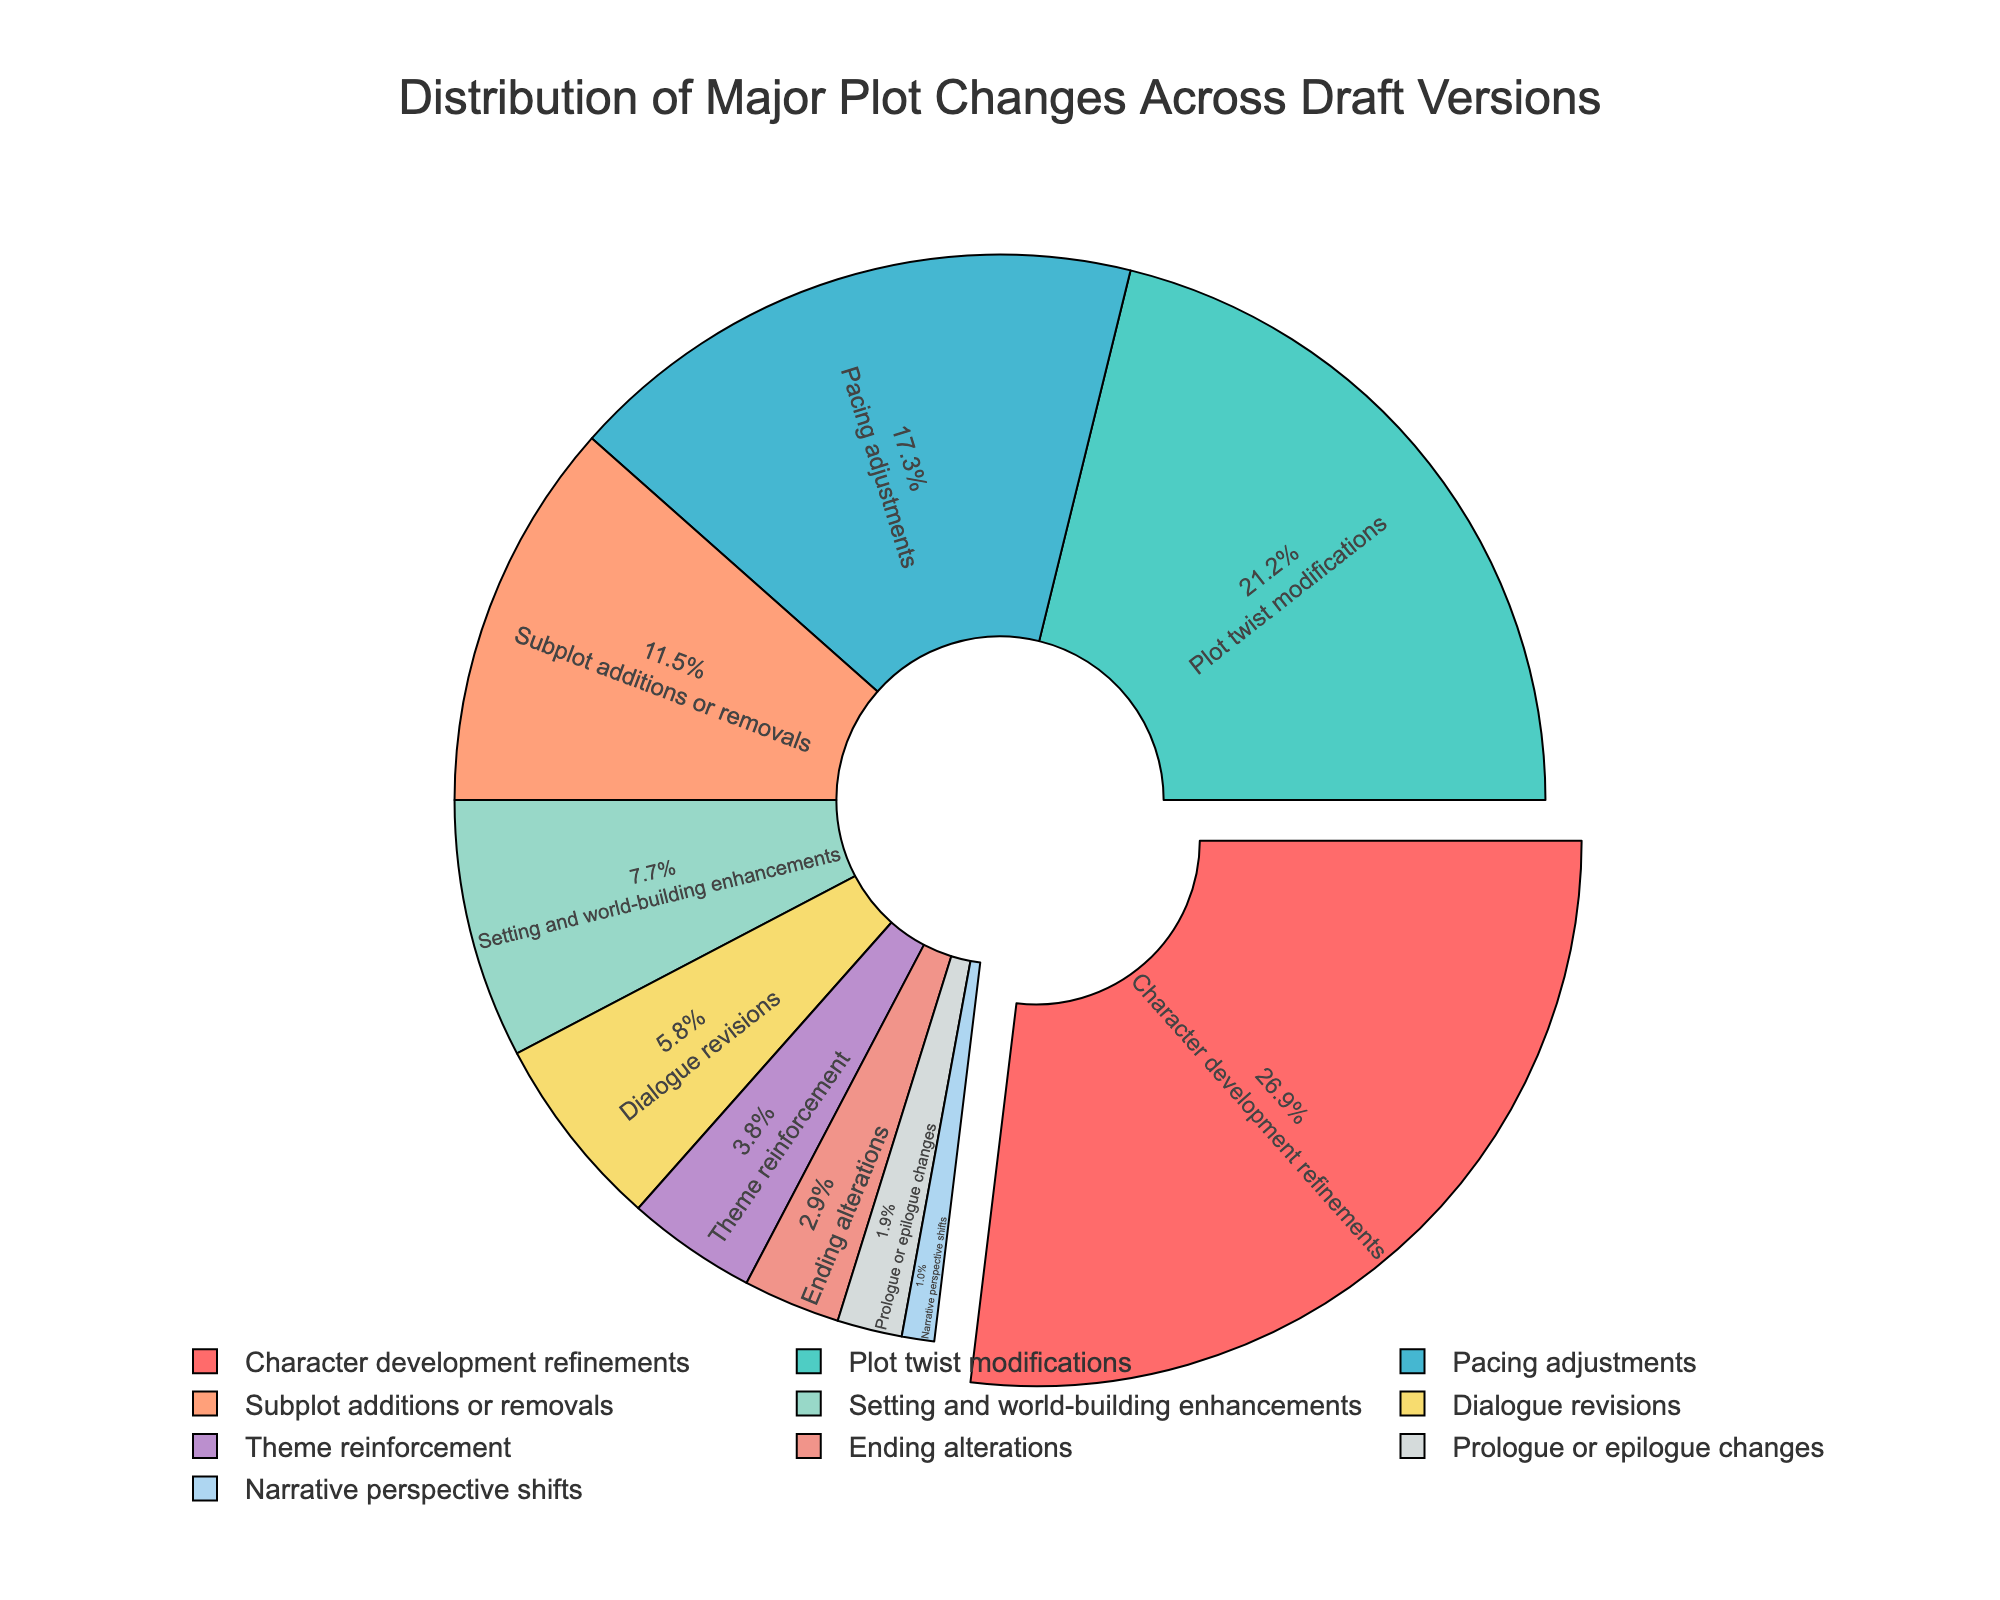Which category accounts for the largest percentage of major plot changes? Look for the segment of the pie chart with the largest percentage. It is labeled as "Character development refinements" with 28%.
Answer: Character development refinements Which two categories combined make up 40% of the major plot changes? Look for two pie segments whose combined percentages equal 40%. The categories "Character development refinements" (28%) and "Dialogue revisions" (6%) combine to 34%, and we can see that "Subplot additions or removals" (12%) also contributes.
Answer: Character development refinements and Subplot additions or removals How much more common are "Pacing adjustments" compared to "Dialogue revisions"? Identify the segments for "Pacing adjustments" and "Dialogue revisions". Pacing adjustments have 18% and Dialogue revisions have 6%. Subtract 6 from 18 to find the difference.
Answer: 12% What is the smallest category in terms of percentage? Find the segment with the smallest percentage. The smallest segment is labeled "Narrative perspective shifts" with 1%.
Answer: Narrative perspective shifts What percentage of plot changes are related to thematic elements (theme reinforcement and dialogue revisions combined)? Find the segments labeled "Theme reinforcement" (4%) and "Dialogue revisions" (6%). Add these percentages together: 4% + 6% = 10%.
Answer: 10% Which category is the third most common plot change? Arrange the categories in descending order of percentages. The top three are "Character development refinements" (28%), "Plot twist modifications" (22%), and "Pacing adjustments" (18%). The third one is "Pacing adjustments".
Answer: Pacing adjustments How does the percentage of "Setting and world-building enhancements" compare to "Plot twist modifications"? Identify both segments: "Setting and world-building enhancements" (8%) and "Plot twist modifications" (22%). 22% is greater than 8%.
Answer: Less What combined percentage do "Subplot additions or removals," "Ending alterations," and "Prologue or epilogue changes" account for? Add the percentages for these categories. "Subplot additions or removals" (12%) + "Ending alterations" (3%) + "Prologue or epilogue changes" (2%) = 17%.
Answer: 17% Which colors represent the categories "Plot twist modifications" and "Pacing adjustments"? Identify the segments and their colors. "Plot twist modifications" is represented by a turquoise color and "Pacing adjustments" by a blue color.
Answer: Turquoise and blue How many categories have a percentage of 5% or lower? Identify the segments with percentages of 5% or lower. The categories are "Dialogue revisions" (6%), "Theme reinforcement" (4%), "Ending alterations" (3%), "Prologue or epilogue changes" (2%), and "Narrative perspective shifts" (1%). This makes four categories.
Answer: 4 